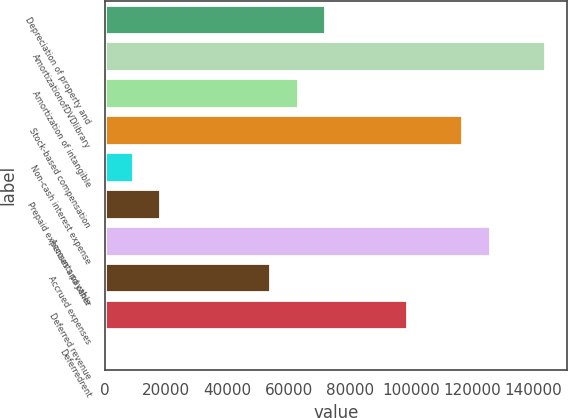Convert chart to OTSL. <chart><loc_0><loc_0><loc_500><loc_500><bar_chart><fcel>Depreciation of property and<fcel>AmortizationofDVDlibrary<fcel>Amortization of intangible<fcel>Stock-based compensation<fcel>Non-cash interest expense<fcel>Prepaid expenses and other<fcel>Accounts payable<fcel>Accrued expenses<fcel>Deferred revenue<fcel>Deferredrent<nl><fcel>71924.6<fcel>143802<fcel>62939.9<fcel>116848<fcel>9031.7<fcel>18016.4<fcel>125833<fcel>53955.2<fcel>98878.7<fcel>47<nl></chart> 